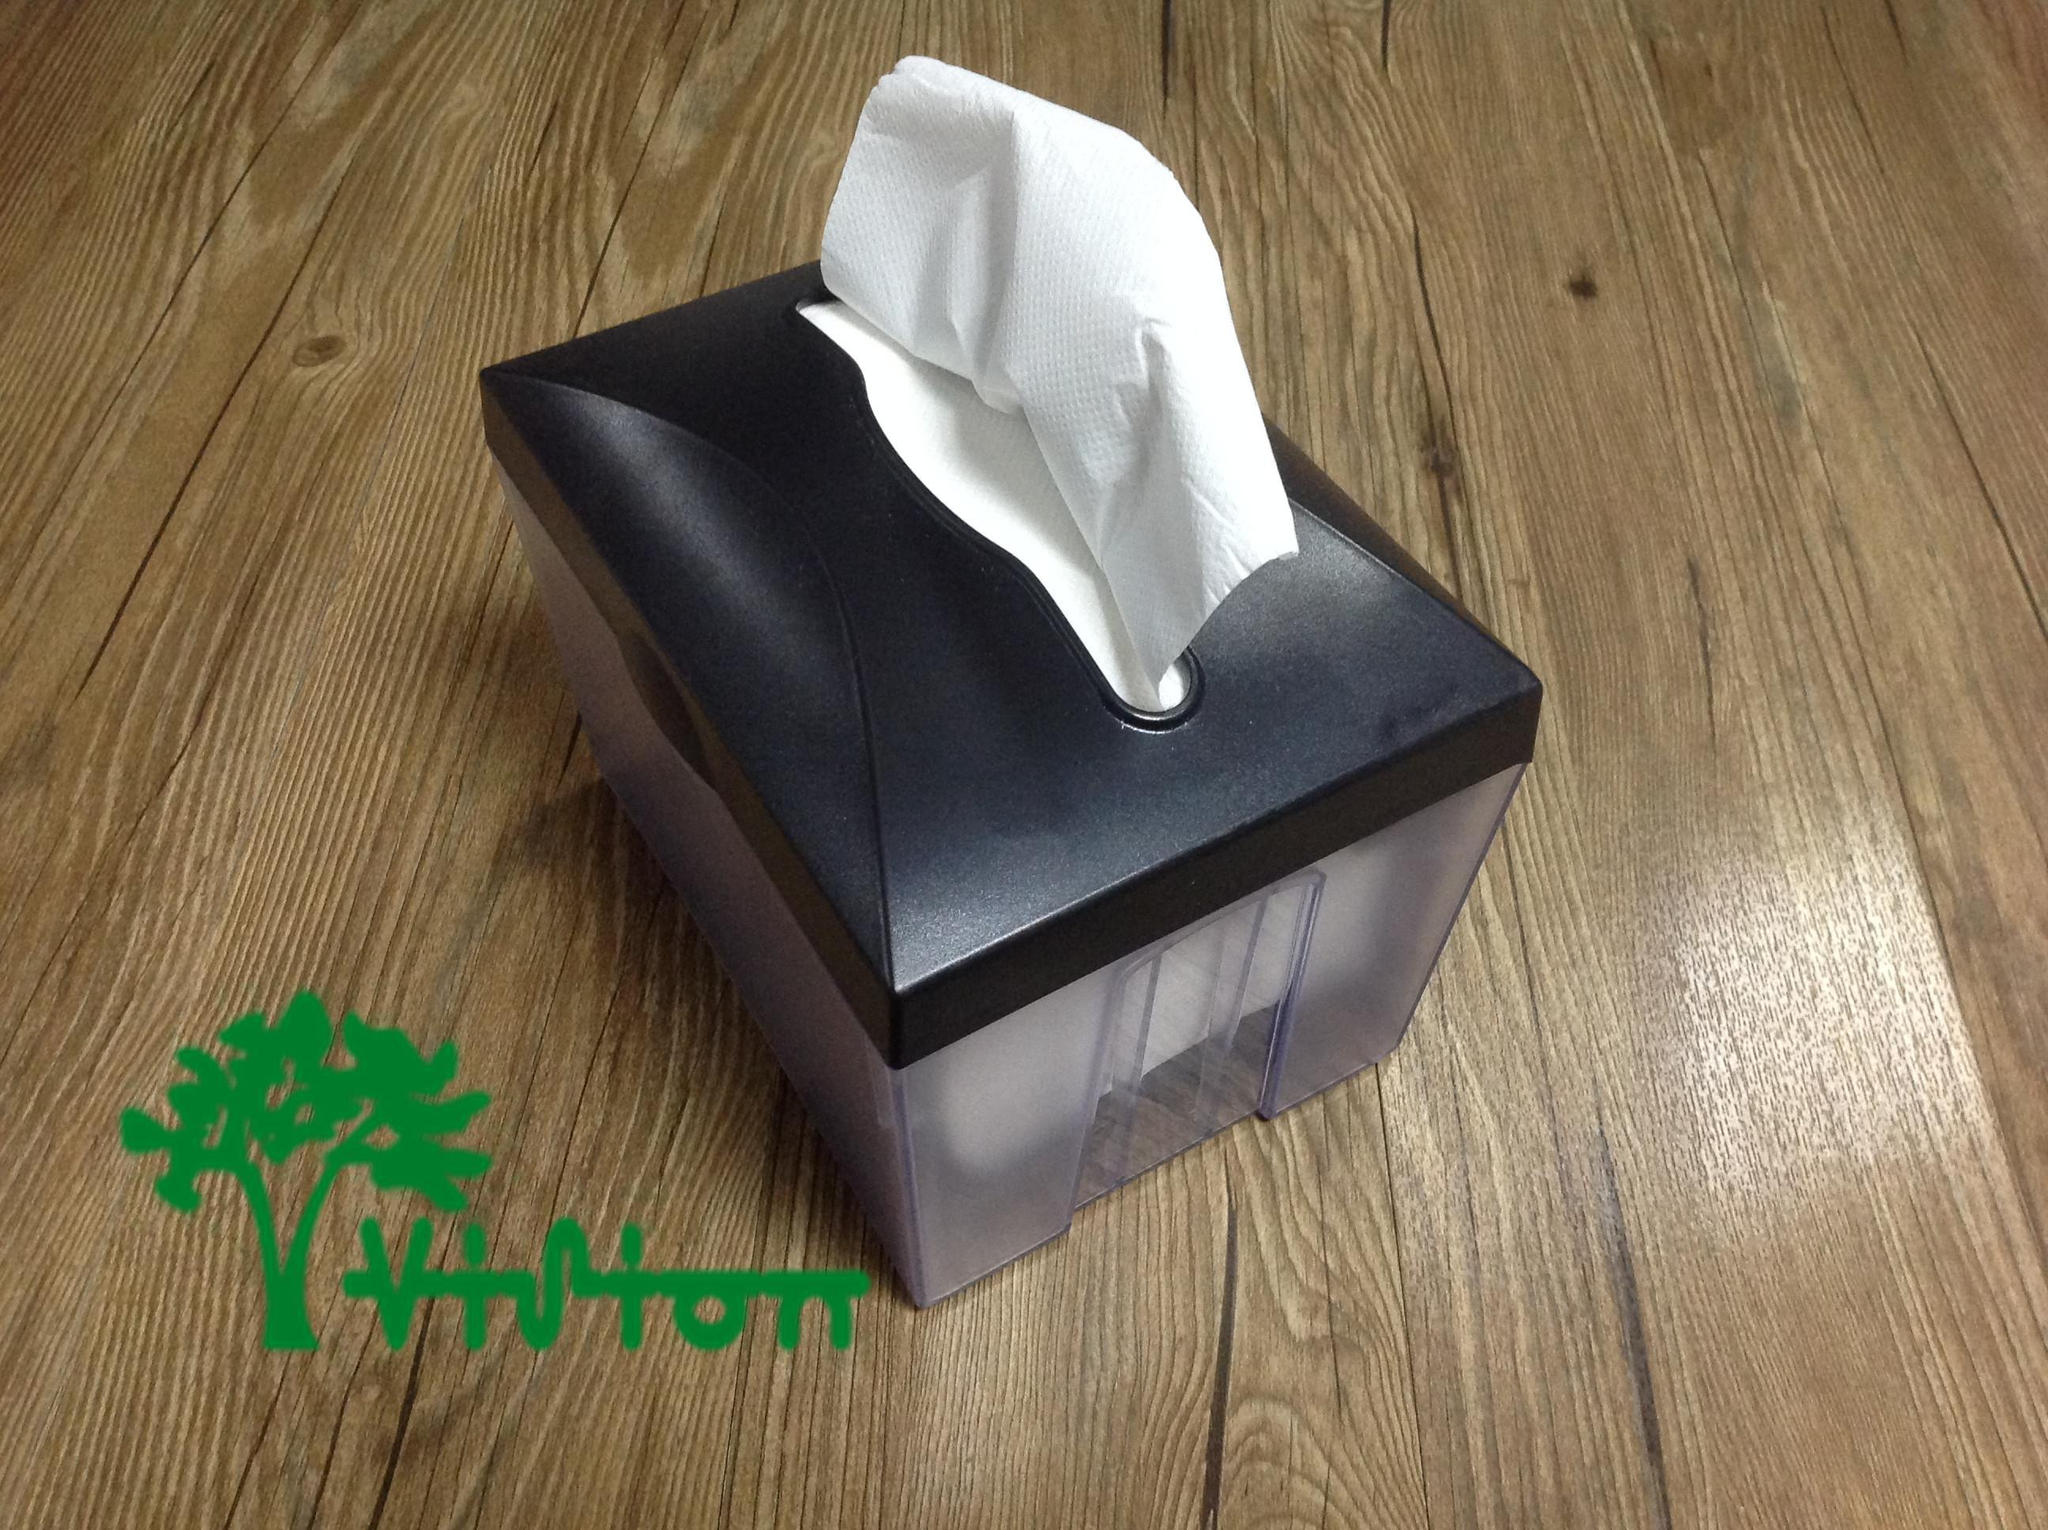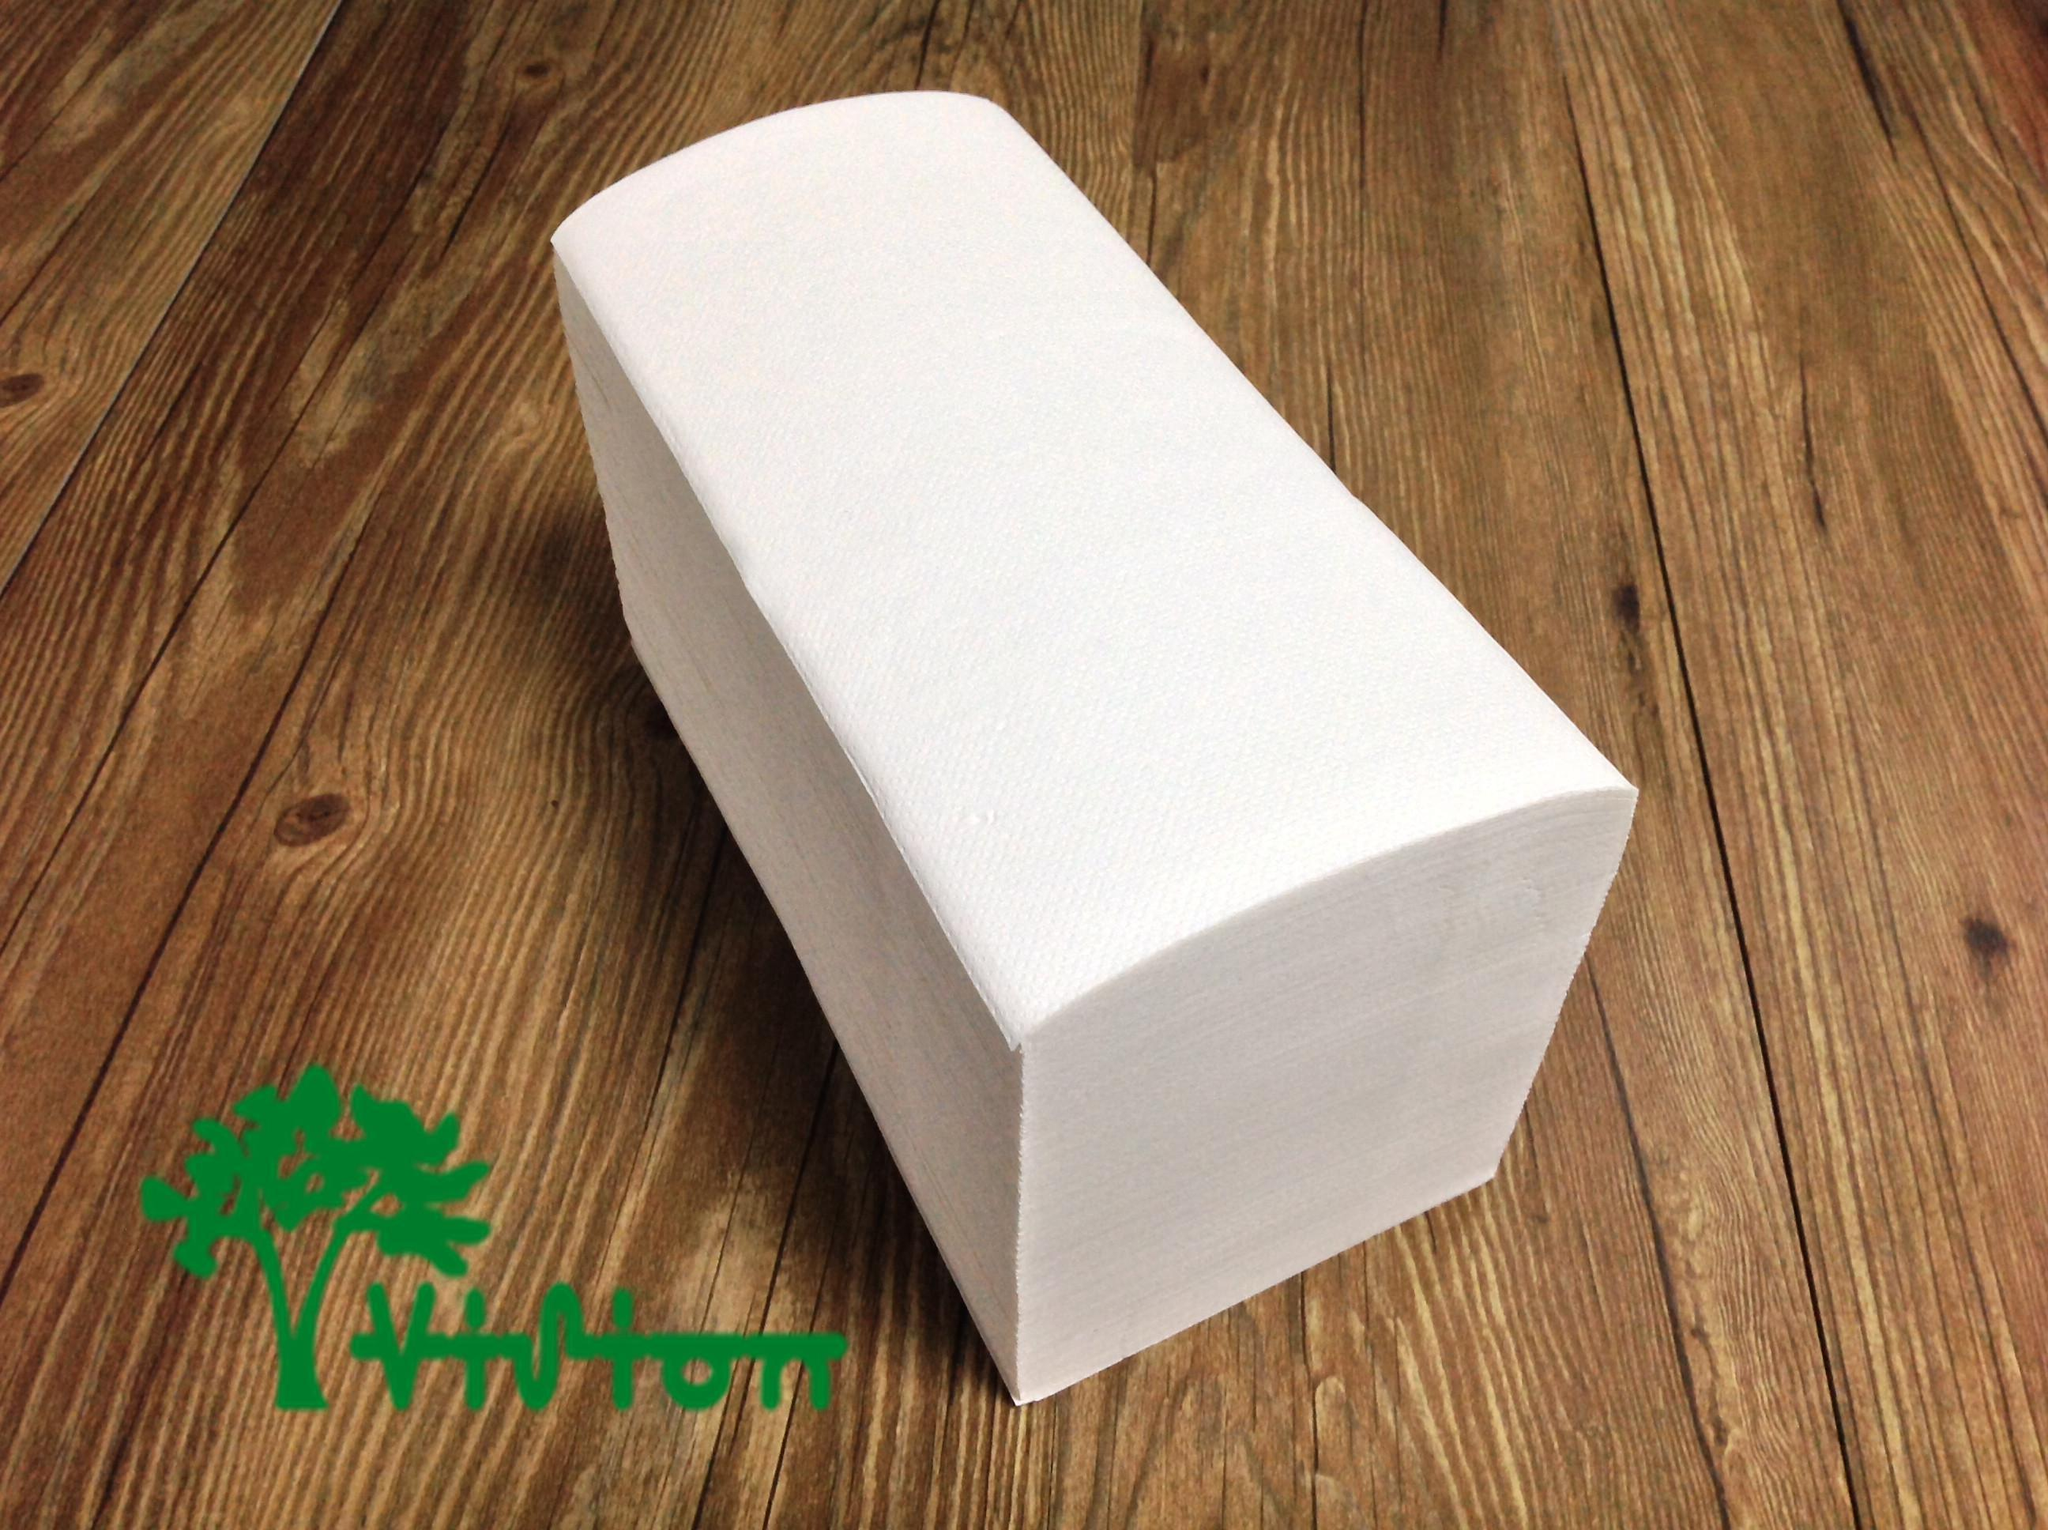The first image is the image on the left, the second image is the image on the right. Assess this claim about the two images: "There are two rolls lying on a wooden surface.". Correct or not? Answer yes or no. No. 